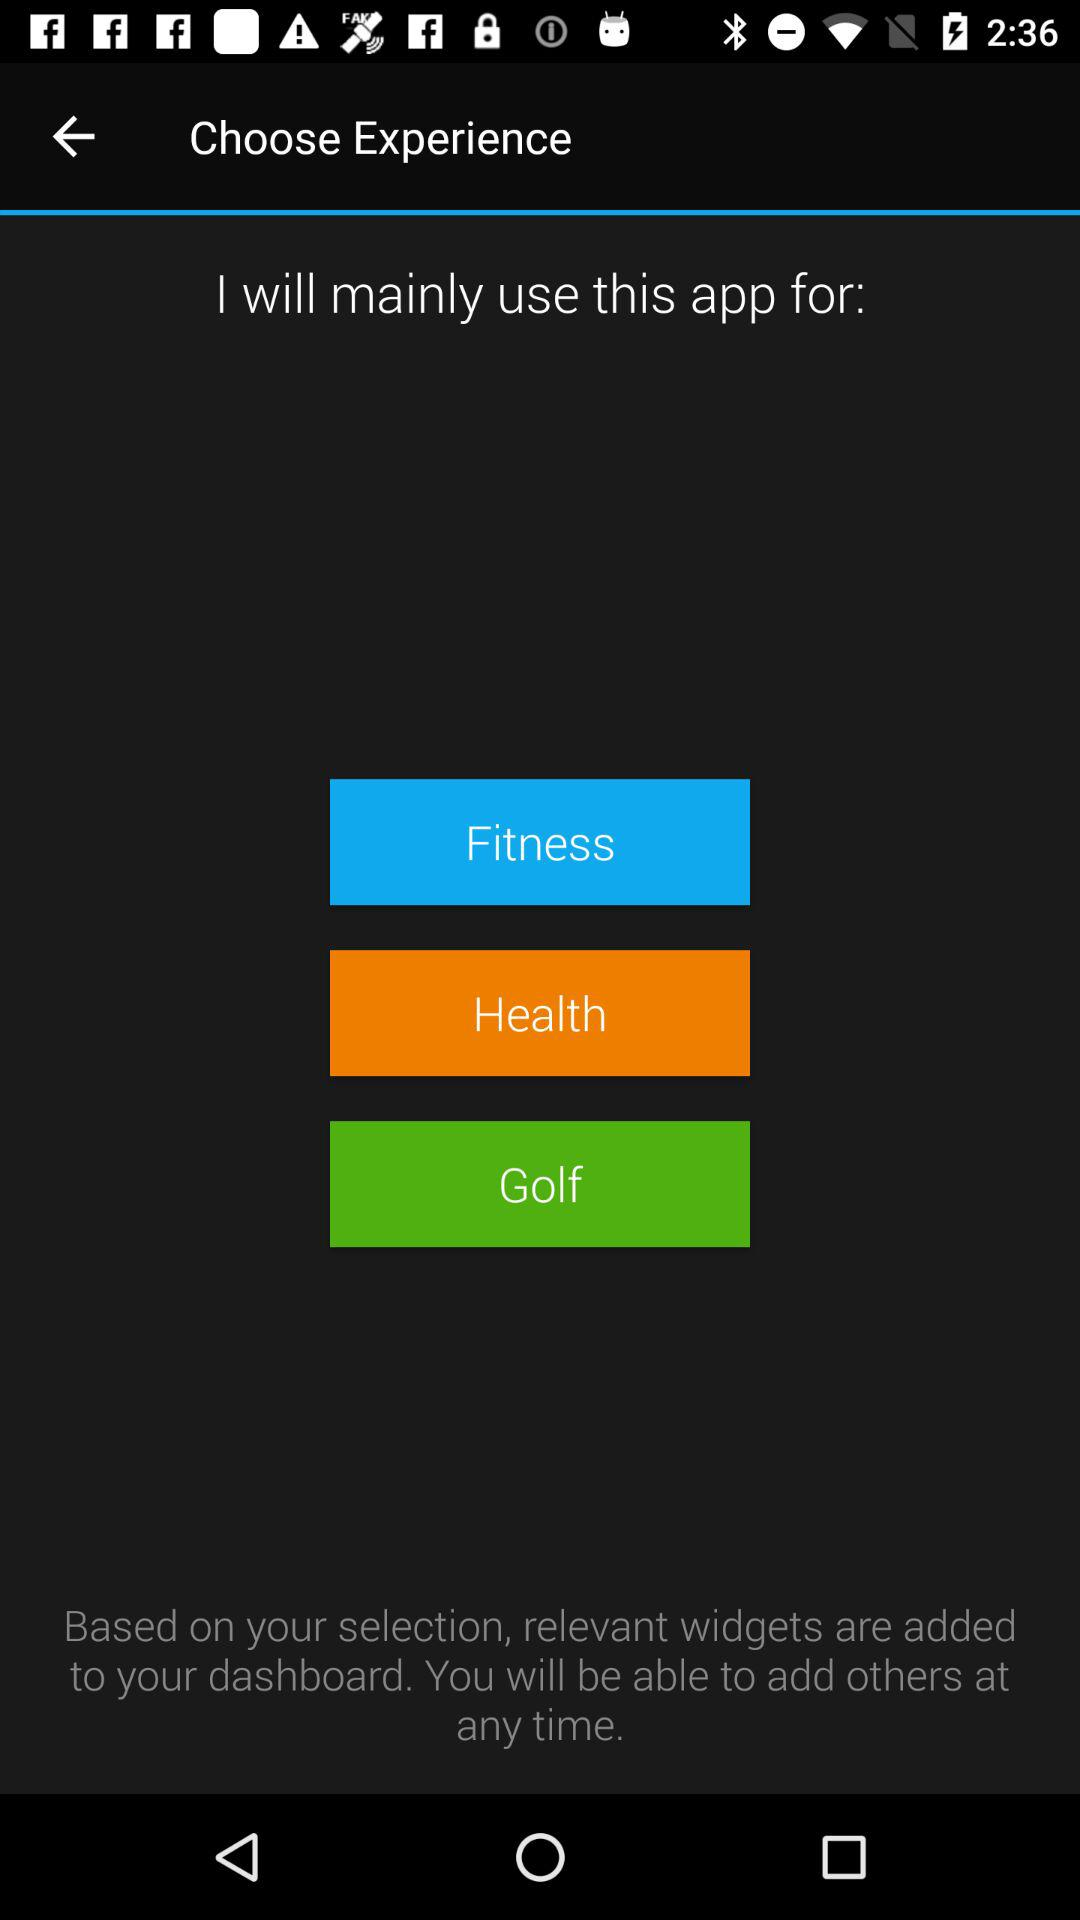Why are you using this application? You are using this application for "Fitness", "Health" and "Golf". 